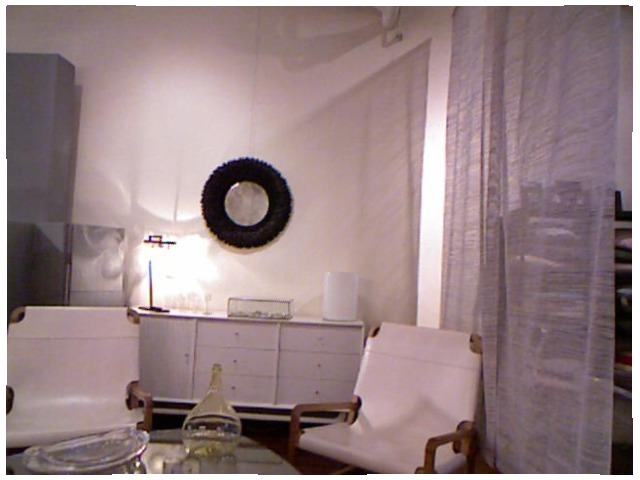<image>
Can you confirm if the chair is in front of the curtains? Yes. The chair is positioned in front of the curtains, appearing closer to the camera viewpoint. Is there a mirror on the wall? Yes. Looking at the image, I can see the mirror is positioned on top of the wall, with the wall providing support. 